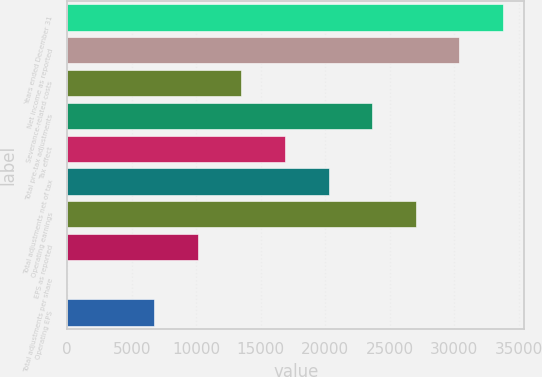Convert chart to OTSL. <chart><loc_0><loc_0><loc_500><loc_500><bar_chart><fcel>Years ended December 31<fcel>Net income as reported<fcel>Severance-related costs<fcel>Total pre-tax adjustments<fcel>Tax effect<fcel>Total adjustments net of tax<fcel>Operating earnings<fcel>EPS as reported<fcel>Total adjustments per share<fcel>Operating EPS<nl><fcel>33753<fcel>30377.7<fcel>13501.2<fcel>23627.1<fcel>16876.5<fcel>20251.8<fcel>27002.4<fcel>10125.9<fcel>0.02<fcel>6750.62<nl></chart> 